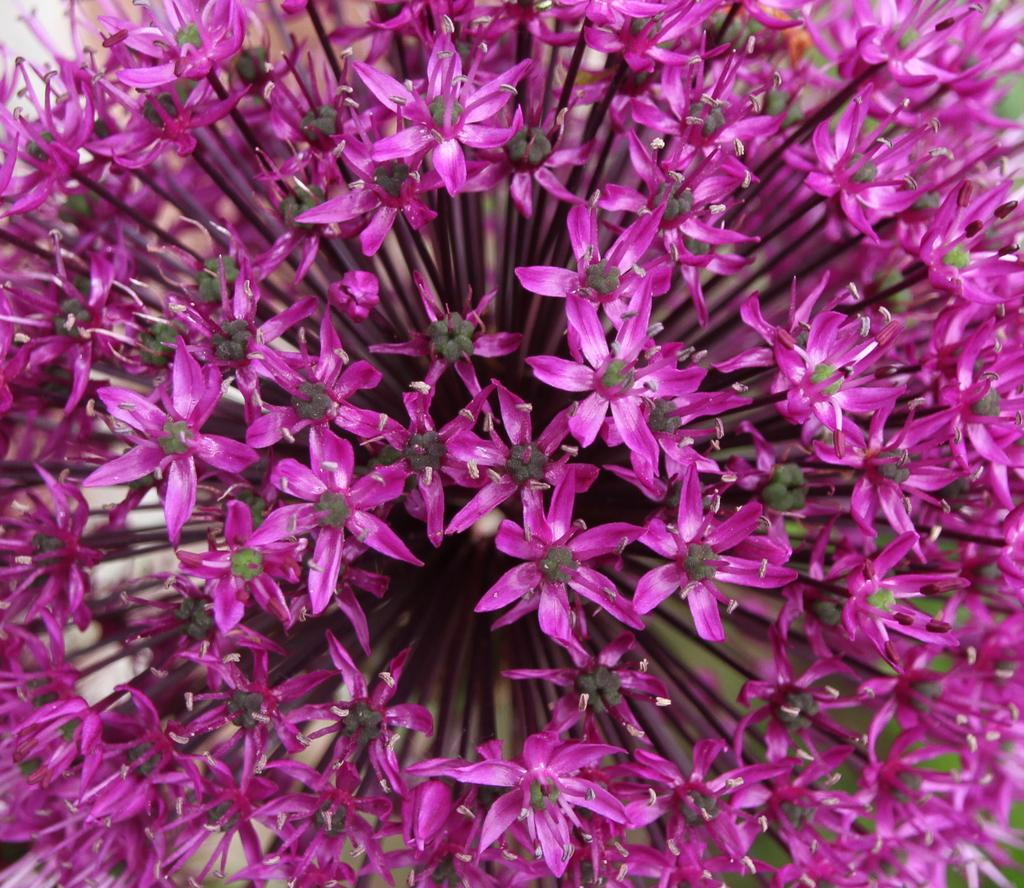What type of plants can be seen in the image? There are flowers in the picture. Can you describe the background of the image? The background of the image is blurred. How many bubbles can be seen floating around the flowers in the image? There are no bubbles present in the image; it features flowers with a blurred background. 